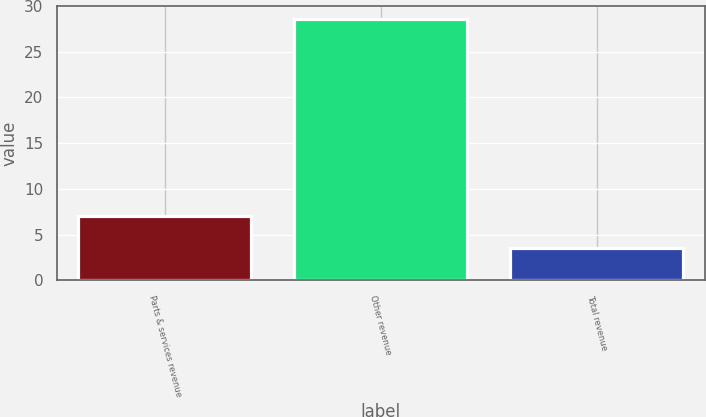Convert chart. <chart><loc_0><loc_0><loc_500><loc_500><bar_chart><fcel>Parts & services revenue<fcel>Other revenue<fcel>Total revenue<nl><fcel>7<fcel>28.6<fcel>3.5<nl></chart> 